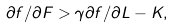<formula> <loc_0><loc_0><loc_500><loc_500>\partial f / \partial F > \gamma \partial f / \partial L - K ,</formula> 